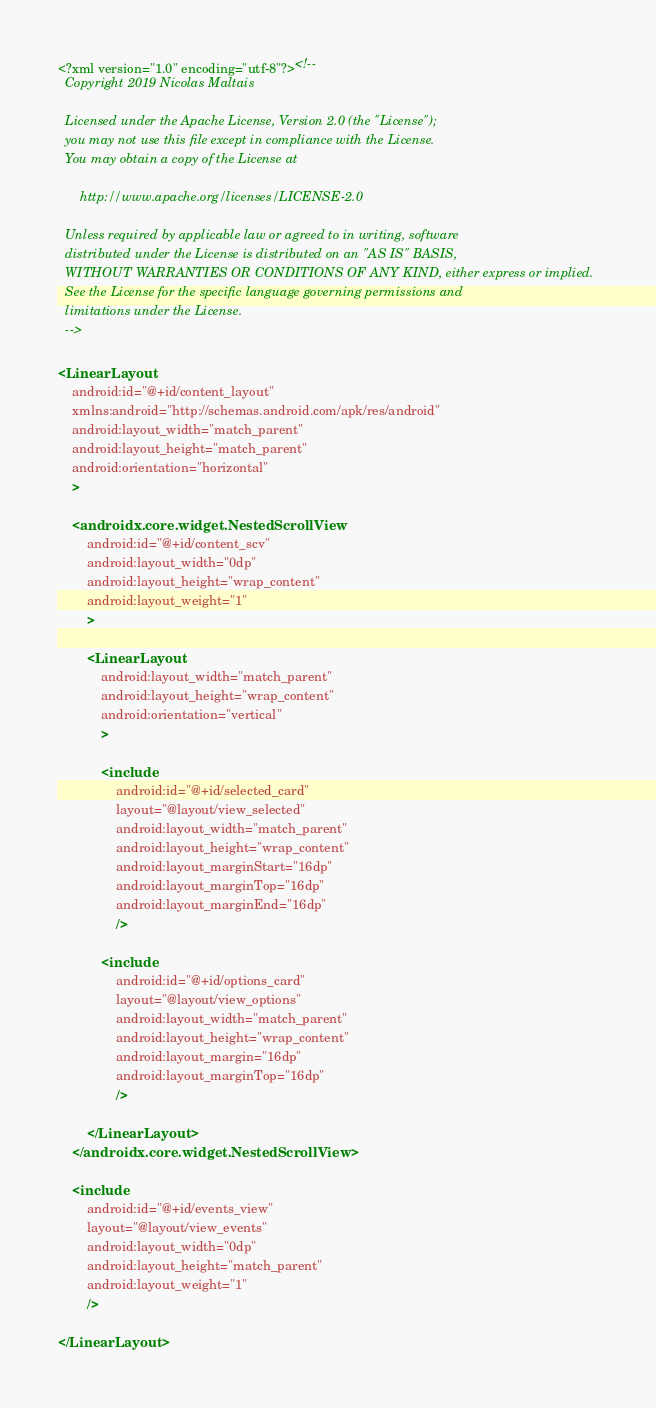<code> <loc_0><loc_0><loc_500><loc_500><_XML_><?xml version="1.0" encoding="utf-8"?><!--
  Copyright 2019 Nicolas Maltais

  Licensed under the Apache License, Version 2.0 (the "License");
  you may not use this file except in compliance with the License.
  You may obtain a copy of the License at

      http://www.apache.org/licenses/LICENSE-2.0

  Unless required by applicable law or agreed to in writing, software
  distributed under the License is distributed on an "AS IS" BASIS,
  WITHOUT WARRANTIES OR CONDITIONS OF ANY KIND, either express or implied.
  See the License for the specific language governing permissions and
  limitations under the License.
  -->

<LinearLayout
    android:id="@+id/content_layout"
    xmlns:android="http://schemas.android.com/apk/res/android"
    android:layout_width="match_parent"
    android:layout_height="match_parent"
    android:orientation="horizontal"
    >

    <androidx.core.widget.NestedScrollView
        android:id="@+id/content_scv"
        android:layout_width="0dp"
        android:layout_height="wrap_content"
        android:layout_weight="1"
        >

        <LinearLayout
            android:layout_width="match_parent"
            android:layout_height="wrap_content"
            android:orientation="vertical"
            >

            <include
                android:id="@+id/selected_card"
                layout="@layout/view_selected"
                android:layout_width="match_parent"
                android:layout_height="wrap_content"
                android:layout_marginStart="16dp"
                android:layout_marginTop="16dp"
                android:layout_marginEnd="16dp"
                />

            <include
                android:id="@+id/options_card"
                layout="@layout/view_options"
                android:layout_width="match_parent"
                android:layout_height="wrap_content"
                android:layout_margin="16dp"
                android:layout_marginTop="16dp"
                />

        </LinearLayout>
    </androidx.core.widget.NestedScrollView>

    <include
        android:id="@+id/events_view"
        layout="@layout/view_events"
        android:layout_width="0dp"
        android:layout_height="match_parent"
        android:layout_weight="1"
        />

</LinearLayout>
</code> 